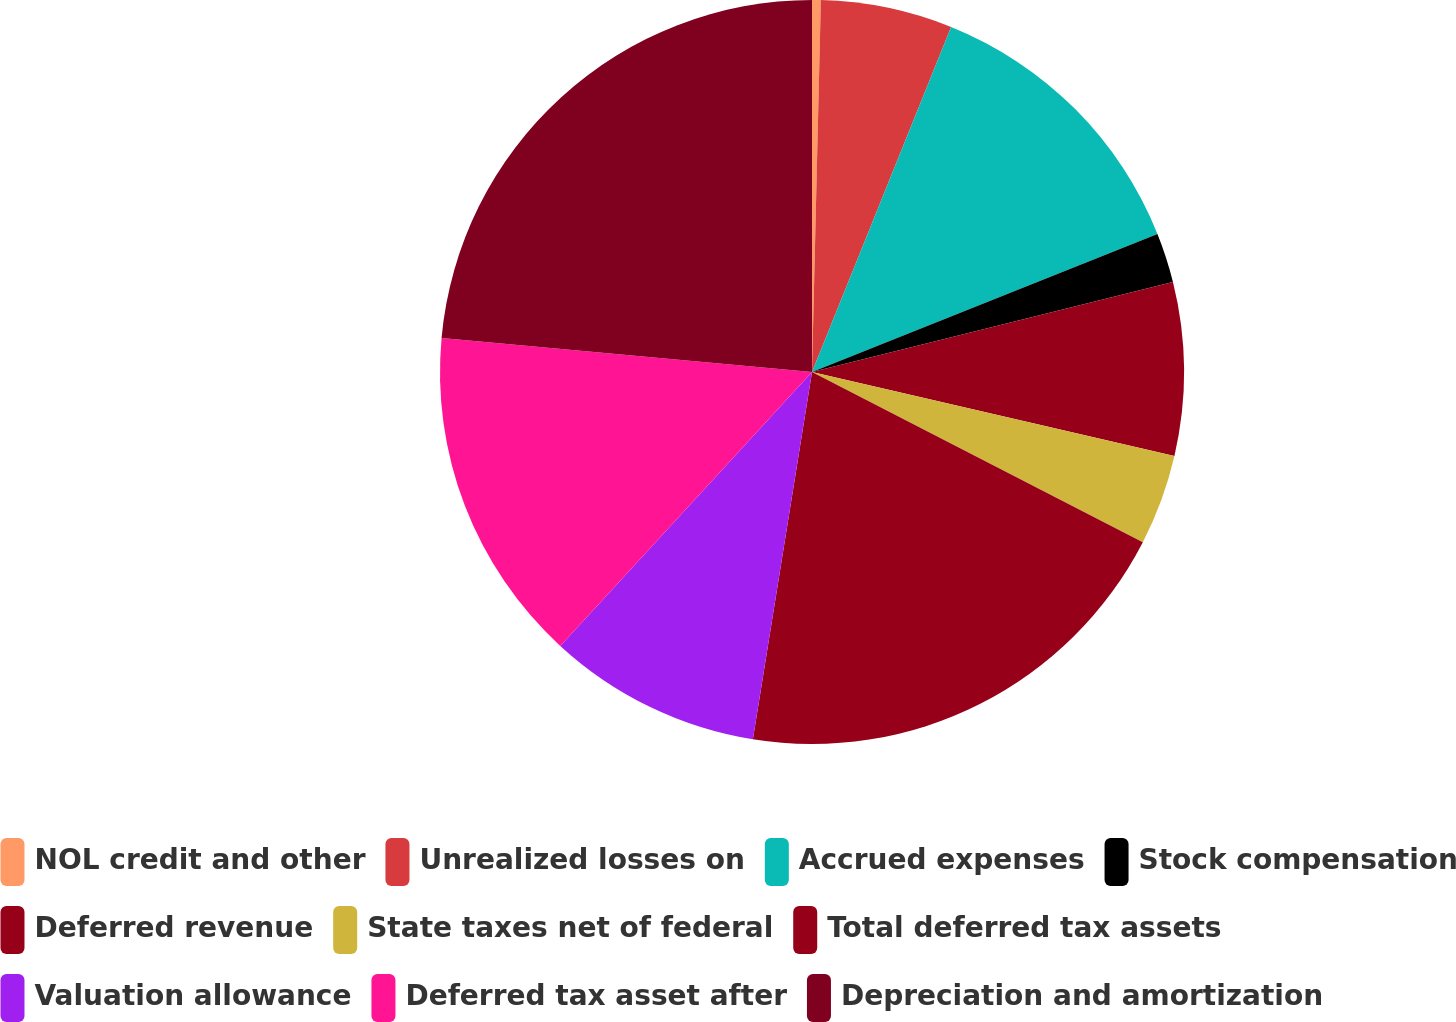<chart> <loc_0><loc_0><loc_500><loc_500><pie_chart><fcel>NOL credit and other<fcel>Unrealized losses on<fcel>Accrued expenses<fcel>Stock compensation<fcel>Deferred revenue<fcel>State taxes net of federal<fcel>Total deferred tax assets<fcel>Valuation allowance<fcel>Deferred tax asset after<fcel>Depreciation and amortization<nl><fcel>0.38%<fcel>5.72%<fcel>12.85%<fcel>2.16%<fcel>7.51%<fcel>3.94%<fcel>19.98%<fcel>9.29%<fcel>14.63%<fcel>23.54%<nl></chart> 